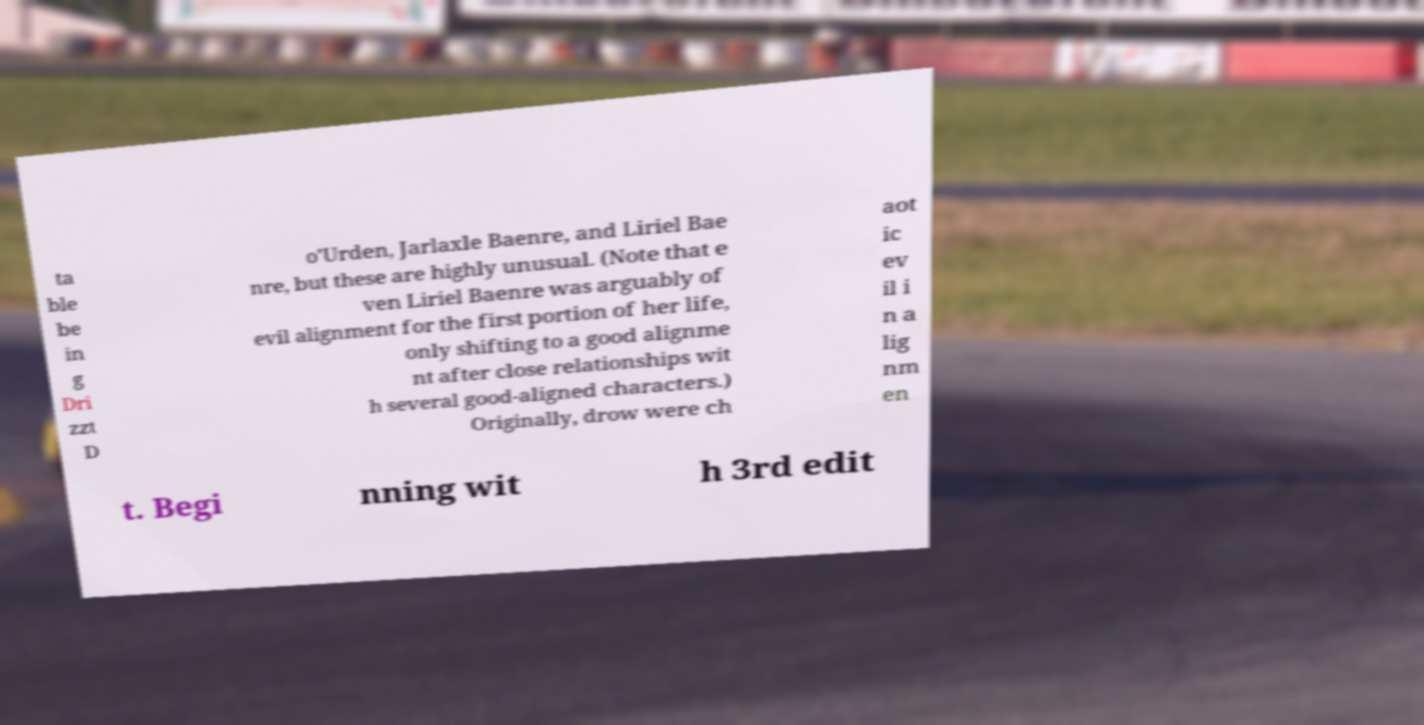What messages or text are displayed in this image? I need them in a readable, typed format. ta ble be in g Dri zzt D o'Urden, Jarlaxle Baenre, and Liriel Bae nre, but these are highly unusual. (Note that e ven Liriel Baenre was arguably of evil alignment for the first portion of her life, only shifting to a good alignme nt after close relationships wit h several good-aligned characters.) Originally, drow were ch aot ic ev il i n a lig nm en t. Begi nning wit h 3rd edit 